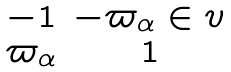<formula> <loc_0><loc_0><loc_500><loc_500>\begin{matrix} - 1 & - \varpi _ { \alpha } \in v \\ \varpi _ { \alpha } & 1 \end{matrix}</formula> 